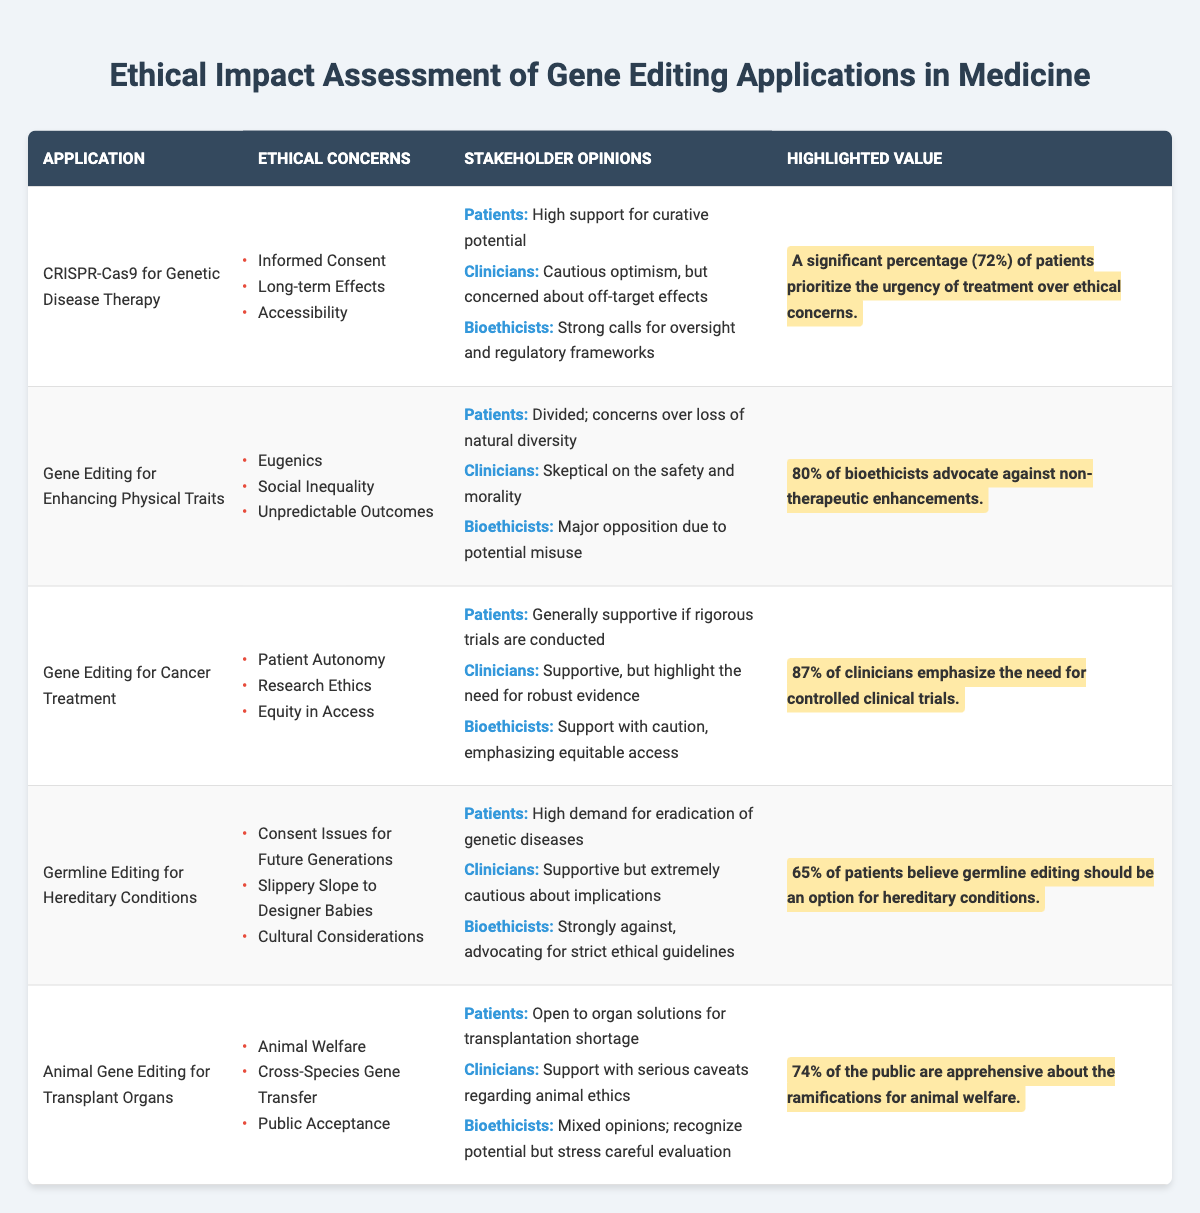What ethical concerns are associated with CRISPR-Cas9 for Genetic Disease Therapy? From the table, under the "Ethical Concerns" column for CRISPR-Cas9 application, the concerns listed are Informed Consent, Long-term Effects, and Accessibility.
Answer: Informed Consent, Long-term Effects, Accessibility Which application has the highest percentage of clinician support for controlled trials? The highlighted value for Gene Editing for Cancer Treatment states that 87% of clinicians emphasize the need for controlled clinical trials, which is the highest percentage presented in the table.
Answer: Gene Editing for Cancer Treatment Do bioethicists support the use of gene editing for enhancing physical traits? The table shows that bioethicists express major opposition to the use of gene editing for enhancing physical traits due to potential misuse.
Answer: No What is the percentage of patients who believe germline editing should be an option for hereditary conditions? The highlighted value for Germline Editing for Hereditary Conditions indicates that 65% of patients believe germline editing should be an option.
Answer: 65% What are the ethical concerns related to Gene Editing for Enhancing Physical Traits? The table lists the ethical concerns for this application as Eugenics, Social Inequality, and Unpredictable Outcomes.
Answer: Eugenics, Social Inequality, Unpredictable Outcomes How many stakeholder opinions are listed for the application of Animal Gene Editing for Transplant Organs? The table mentions three types of stakeholders—Patients, Clinicians, and Bioethicists—each having their opinion presented, indicating there are three stakeholder opinions listed.
Answer: 3 Which application has a significant public apprehension regarding animal welfare? The highlighted value for Animal Gene Editing for Transplant Organs indicates that 74% of the public are apprehensive about the ramifications for animal welfare.
Answer: Animal Gene Editing for Transplant Organs What percentage of bioethicists advocate against non-therapeutic enhancements? The highlighted value for Gene Editing for Enhancing Physical Traits shows that 80% of bioethicists advocate against non-therapeutic enhancements.
Answer: 80% If you combine the percentages of patients supporting CRISPR-Cas9 and germline editing respectively, what is the total percentage? For CRISPR-Cas9, 72% of patients prioritize treatment urgency and for germline editing, 65% believe it should be an option. Adding these: 72 + 65 = 137.
Answer: 137 Is there a concern about loss of natural diversity among patients regarding gene editing for enhancing physical traits? Yes, the table mentions in the stakeholder opinions that patients are divided and concerned over the loss of natural diversity with this type of gene editing.
Answer: Yes What ethical concern is unique to Germline Editing for Hereditary Conditions compared to other applications in the table? The unique ethical concern listed for Germline Editing is "Consent Issues for Future Generations," which is not mentioned in other applications.
Answer: Consent Issues for Future Generations 